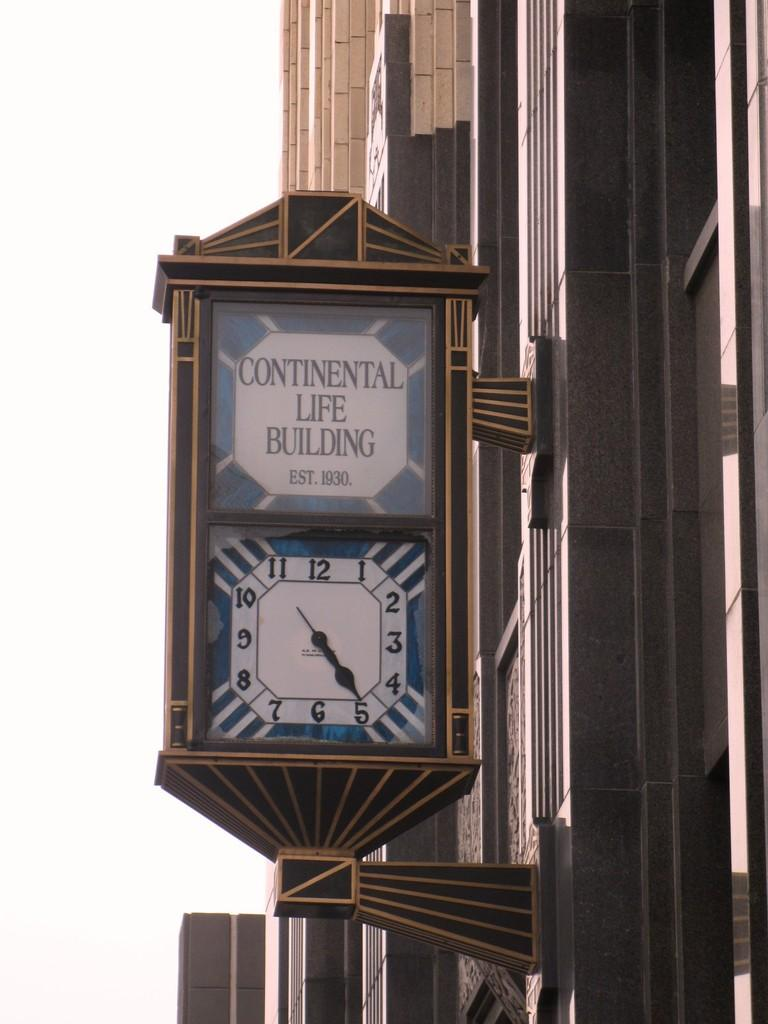<image>
Share a concise interpretation of the image provided. a sign that is outside of a building that says continental life building 